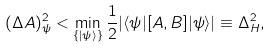<formula> <loc_0><loc_0><loc_500><loc_500>( \Delta A ) _ { \psi } ^ { 2 } < \min _ { \{ | \psi \rangle \} } \frac { 1 } { 2 } | \langle \psi | [ A , B ] | \psi \rangle | \equiv \Delta _ { H } ^ { 2 } ,</formula> 